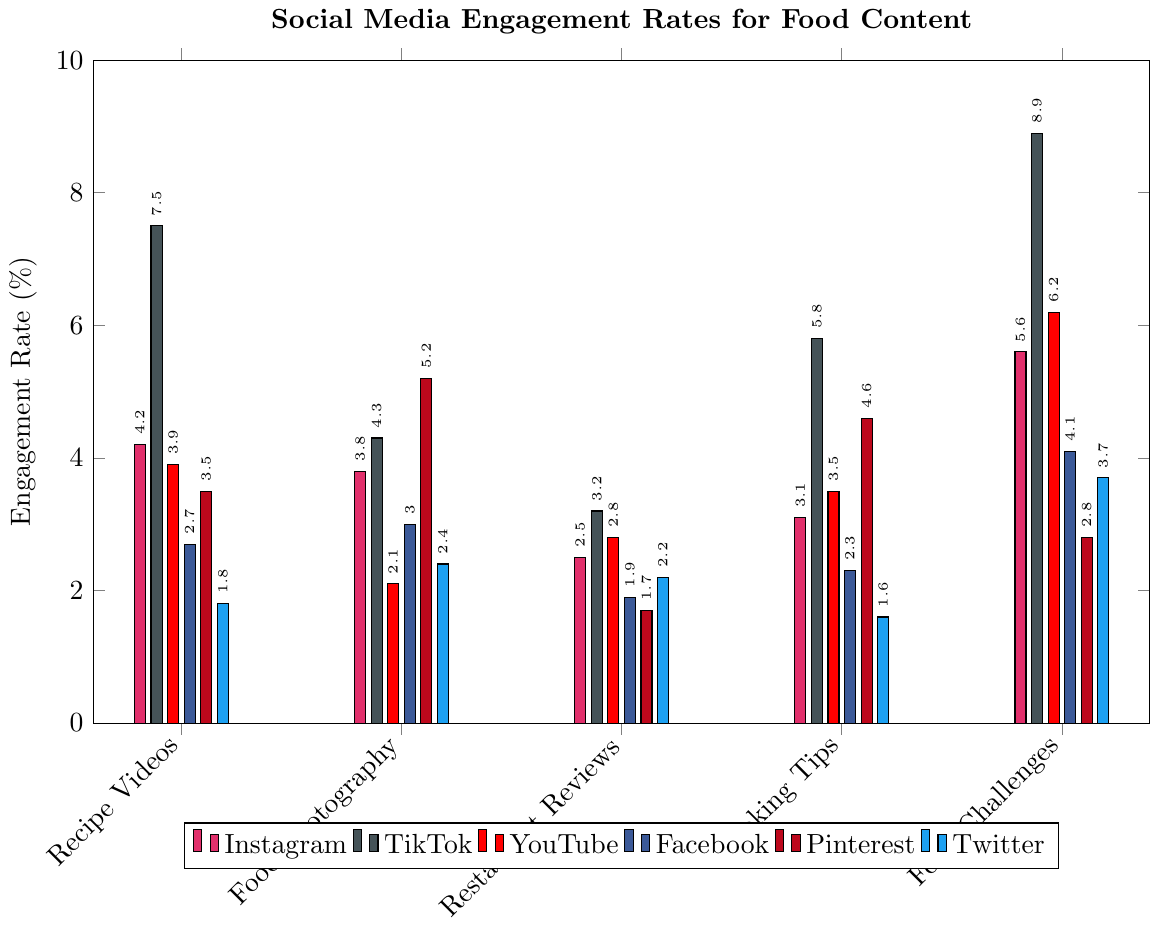Which type of food content has the highest engagement rate on TikTok? Identify the highest value in the TikTok column. The values are: Recipe Videos (7.5%), Food Photography (4.3%), Restaurant Reviews (3.2%), Cooking Tips (5.8%), Food Challenges (8.9%). The highest value is for Food Challenges.
Answer: Food Challenges Which platform has the lowest engagement rate for restaurant reviews? Identify the lowest value in the Restaurant Reviews row. The values are: Instagram (2.5%), TikTok (3.2%), YouTube (2.8%), Facebook (1.9%), Pinterest (1.7%), Twitter (2.2%). The lowest value is for Pinterest.
Answer: Pinterest What's the sum of engagement rates for Recipe Videos and Cooking Tips on YouTube? Add the values for Recipe Videos and Cooking Tips on YouTube. Recipe Videos is 3.9% and Cooking Tips is 3.5%. Sum = 3.9% + 3.5% = 7.4%.
Answer: 7.4% Which two platforms have the closest engagement rates for Food Photography? Compare the values for Food Photography across all platforms: Instagram (3.8%), TikTok (4.3%), YouTube (2.1%), Facebook (3.0%), Pinterest (5.2%), Twitter (2.4%). The closest values are Instagram (3.8%) and Facebook (3.0%), with a difference of 0.8%, which is the smallest difference.
Answer: Instagram and Facebook On which platform is the visual difference between Food Photography and Restaurant Reviews most noticeable? Find the difference between Food Photography and Restaurant Reviews for each platform. The differences are: Instagram (3.8% - 2.5% = 1.3%), TikTok (4.3% - 3.2% = 1.1%), YouTube (2.1% - 2.8% = -0.7%), Facebook (3.0% - 1.9% = 1.1%), Pinterest (5.2% - 1.7% = 3.5%), Twitter (2.4% - 2.2% = 0.2%). The most noticeable difference is on Pinterest (3.5%).
Answer: Pinterest Which type of food content has the highest overall engagement rate when averaged across all platforms? Find the average engagement rate for each content type:
- Recipe Videos: (4.2% + 7.5% + 3.9% + 2.7% + 3.5% + 1.8%) / 6 = 23.6% / 6 = 3.93%
- Food Photography: (3.8% + 4.3% + 2.1% + 3.0% + 5.2% + 2.4%) / 6 = 20.8% / 6 ≈ 3.47%
- Restaurant Reviews: (2.5% + 3.2% + 2.8% + 1.9% + 1.7% + 2.2%) / 6 = 14.3% / 6 ≈ 2.38%
- Cooking Tips: (3.1% + 5.8% + 3.5% + 2.3% + 4.6% + 1.6%) / 6 = 20.9% / 6 ≈ 3.48%
- Food Challenges: (5.6% + 8.9% + 6.2% + 4.1% + 2.8% + 3.7%) / 6 = 31.3% / 6 ≈ 5.22%
The highest average engagement rate is for Food Challenges.
Answer: Food Challenges Which type of food content has a higher engagement rate on Instagram compared to Twitter? Compare values for Instagram and Twitter for each content type:
- Recipe Videos: Instagram (4.2%) vs Twitter (1.8%) - Yes
- Food Photography: Instagram (3.8%) vs Twitter (2.4%) - Yes
- Restaurant Reviews: Instagram (2.5%) vs Twitter (2.2%) - Yes
- Cooking Tips: Instagram (3.1%) vs Twitter (1.6%) - Yes
- Food Challenges: Instagram (5.6%) vs Twitter (3.7%) - Yes
All content types have higher engagement rates on Instagram compared to Twitter.
Answer: All types 